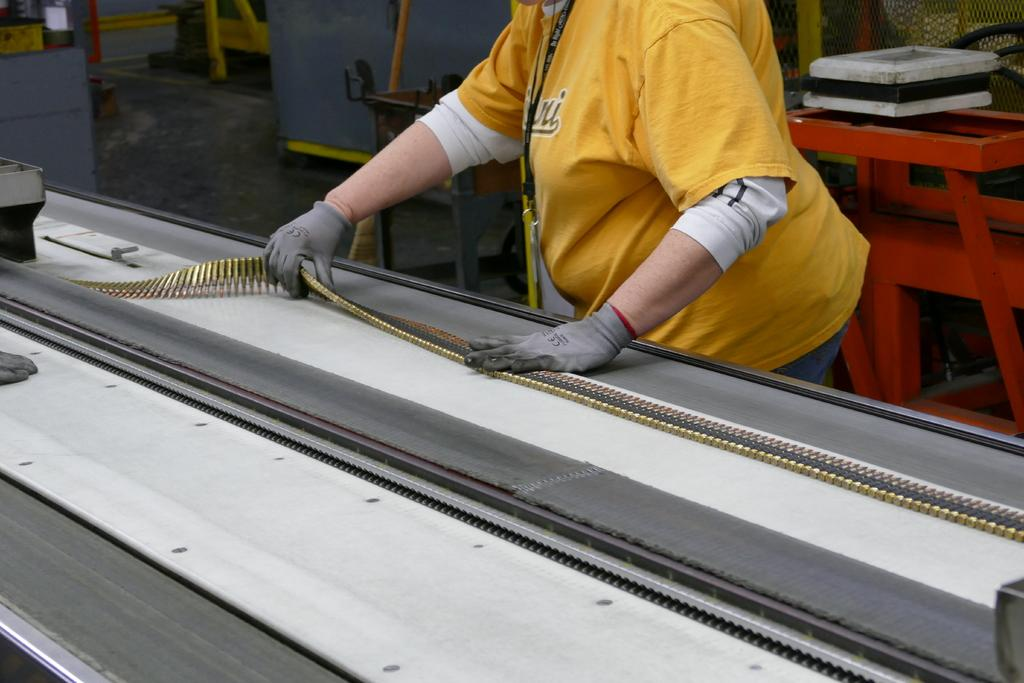Who or what is present in the image? There is a person in the image. What is the person wearing? The person is wearing a yellow t-shirt. What objects are in front of the person? There are bullets in front of the person. What type of toys can be seen in the person's hands in the image? There are no toys present in the image; the person is not holding anything, and the only objects mentioned are bullets. 